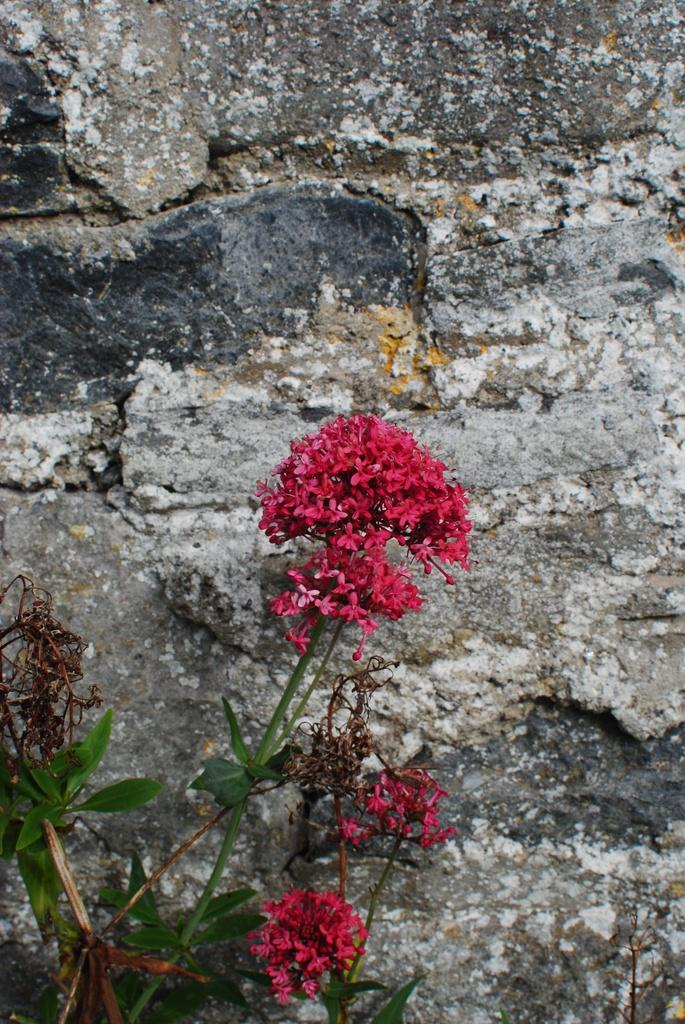What type of plant is visible in the image? There is a plant with flowers in the image. What can be seen behind the plant in the image? The background of the image appears to be a wall. What time of day is it in the image, and who is playing chess? There is no information about the time of day or any chess game in the image. The image only features a plant with flowers and a wall in the background. 